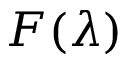Convert formula to latex. <formula><loc_0><loc_0><loc_500><loc_500>F ( \lambda )</formula> 